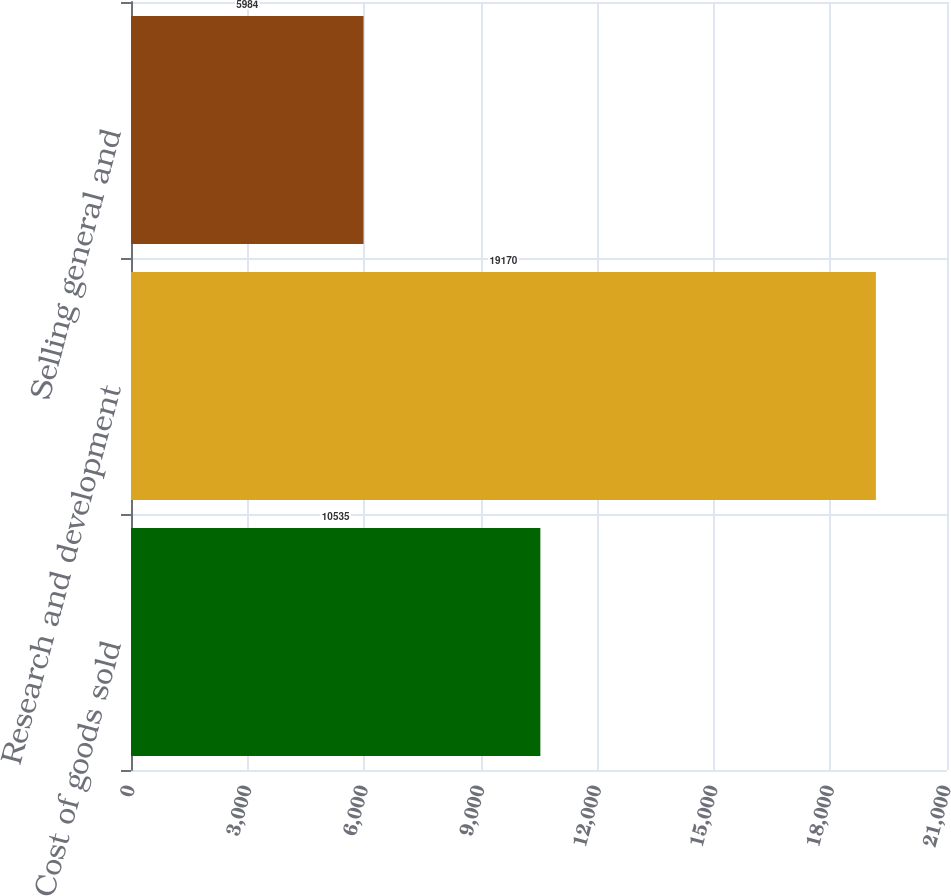Convert chart. <chart><loc_0><loc_0><loc_500><loc_500><bar_chart><fcel>Cost of goods sold<fcel>Research and development<fcel>Selling general and<nl><fcel>10535<fcel>19170<fcel>5984<nl></chart> 